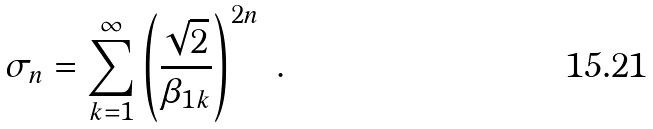<formula> <loc_0><loc_0><loc_500><loc_500>\sigma _ { n } = \sum _ { k = 1 } ^ { \infty } \left ( \frac { \sqrt { 2 } } { \beta _ { 1 k } } \right ) ^ { 2 n } \ .</formula> 